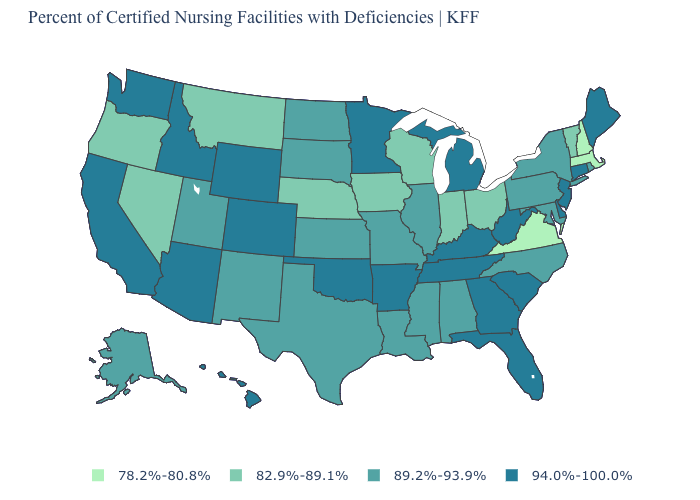Does the first symbol in the legend represent the smallest category?
Write a very short answer. Yes. Does Virginia have the lowest value in the USA?
Be succinct. Yes. What is the value of Ohio?
Write a very short answer. 82.9%-89.1%. Name the states that have a value in the range 82.9%-89.1%?
Answer briefly. Indiana, Iowa, Montana, Nebraska, Nevada, Ohio, Oregon, Vermont, Wisconsin. Does the first symbol in the legend represent the smallest category?
Be succinct. Yes. Name the states that have a value in the range 82.9%-89.1%?
Give a very brief answer. Indiana, Iowa, Montana, Nebraska, Nevada, Ohio, Oregon, Vermont, Wisconsin. Name the states that have a value in the range 89.2%-93.9%?
Keep it brief. Alabama, Alaska, Illinois, Kansas, Louisiana, Maryland, Mississippi, Missouri, New Mexico, New York, North Carolina, North Dakota, Pennsylvania, Rhode Island, South Dakota, Texas, Utah. Does Pennsylvania have the lowest value in the Northeast?
Give a very brief answer. No. Which states have the lowest value in the Northeast?
Keep it brief. Massachusetts, New Hampshire. Which states hav the highest value in the West?
Short answer required. Arizona, California, Colorado, Hawaii, Idaho, Washington, Wyoming. What is the value of Maryland?
Quick response, please. 89.2%-93.9%. Among the states that border Nebraska , which have the lowest value?
Quick response, please. Iowa. Which states have the highest value in the USA?
Concise answer only. Arizona, Arkansas, California, Colorado, Connecticut, Delaware, Florida, Georgia, Hawaii, Idaho, Kentucky, Maine, Michigan, Minnesota, New Jersey, Oklahoma, South Carolina, Tennessee, Washington, West Virginia, Wyoming. Among the states that border Maryland , does West Virginia have the lowest value?
Be succinct. No. What is the value of Montana?
Answer briefly. 82.9%-89.1%. 